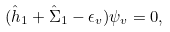<formula> <loc_0><loc_0><loc_500><loc_500>( \hat { h } _ { 1 } + \hat { \Sigma } _ { 1 } - \epsilon _ { v } ) \psi _ { v } = 0 ,</formula> 